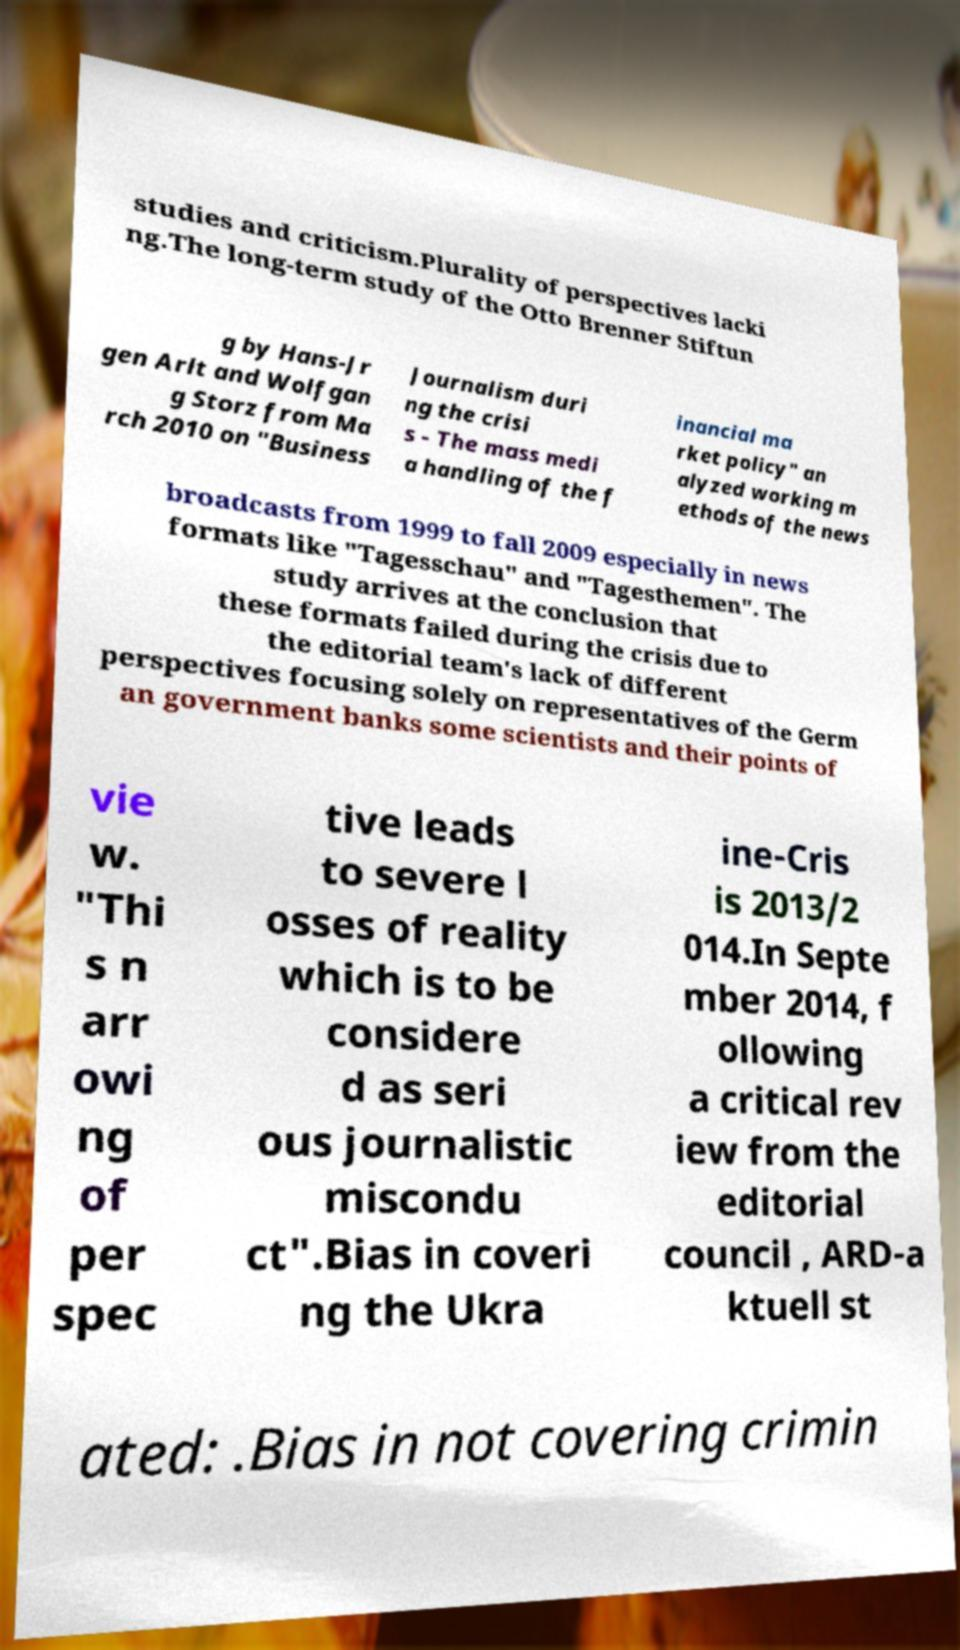I need the written content from this picture converted into text. Can you do that? studies and criticism.Plurality of perspectives lacki ng.The long-term study of the Otto Brenner Stiftun g by Hans-Jr gen Arlt and Wolfgan g Storz from Ma rch 2010 on "Business Journalism duri ng the crisi s - The mass medi a handling of the f inancial ma rket policy" an alyzed working m ethods of the news broadcasts from 1999 to fall 2009 especially in news formats like "Tagesschau" and "Tagesthemen". The study arrives at the conclusion that these formats failed during the crisis due to the editorial team's lack of different perspectives focusing solely on representatives of the Germ an government banks some scientists and their points of vie w. "Thi s n arr owi ng of per spec tive leads to severe l osses of reality which is to be considere d as seri ous journalistic miscondu ct".Bias in coveri ng the Ukra ine-Cris is 2013/2 014.In Septe mber 2014, f ollowing a critical rev iew from the editorial council , ARD-a ktuell st ated: .Bias in not covering crimin 